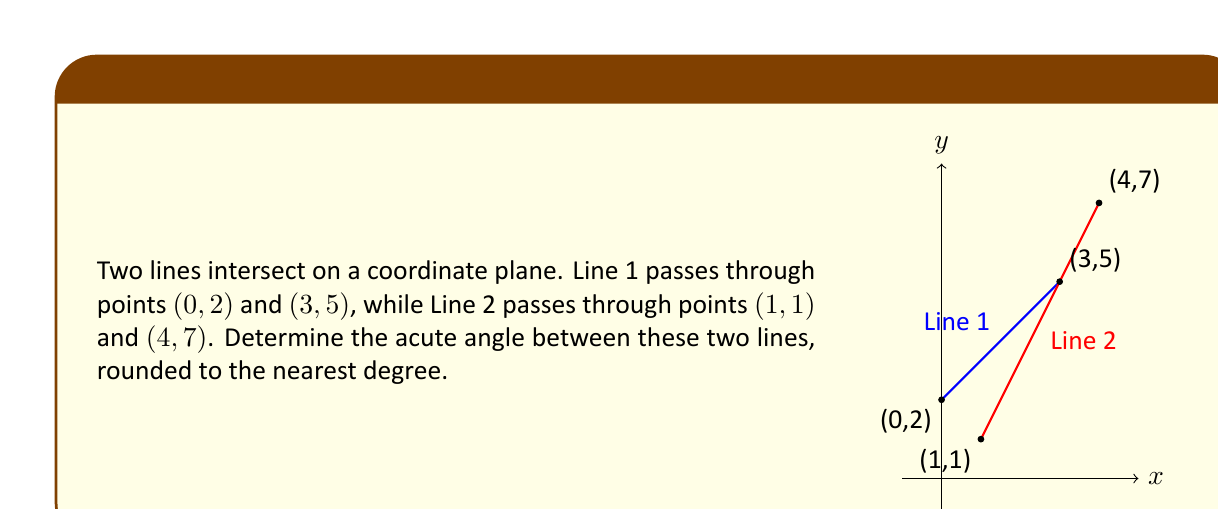Solve this math problem. To find the angle between two lines, we can follow these steps:

1. Calculate the slopes of both lines:
   For Line 1: $m_1 = \frac{y_2 - y_1}{x_2 - x_1} = \frac{5 - 2}{3 - 0} = 1$
   For Line 2: $m_2 = \frac{y_2 - y_1}{x_2 - x_1} = \frac{7 - 1}{4 - 1} = 2$

2. Use the formula for the angle between two lines:
   $\tan \theta = |\frac{m_2 - m_1}{1 + m_1m_2}|$

3. Substitute the slopes into the formula:
   $\tan \theta = |\frac{2 - 1}{1 + 1 \cdot 2}| = |\frac{1}{3}|$

4. Take the inverse tangent (arctangent) of both sides:
   $\theta = \arctan(\frac{1}{3})$

5. Convert the result to degrees:
   $\theta = \arctan(\frac{1}{3}) \cdot \frac{180}{\pi} \approx 18.43°$

6. Round to the nearest degree:
   $\theta \approx 18°$

This gives us the acute angle between the two lines.
Answer: $18°$ 